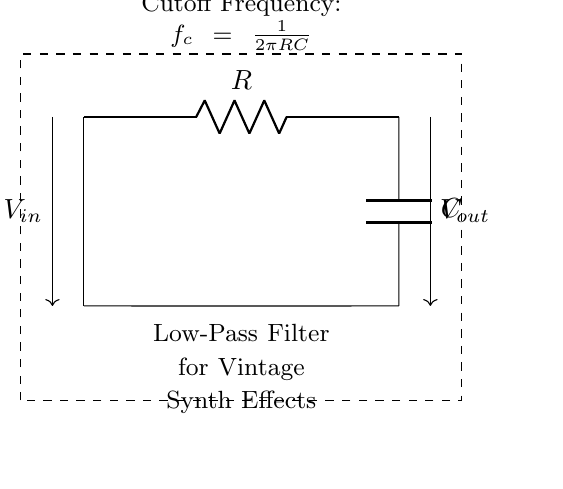What type of components are present in the circuit? The circuit consists of a resistor and a capacitor, which are the two essential components in a low-pass filter. The resistor is labeled as R, and the capacitor is labeled as C.
Answer: Resistor, Capacitor What is the purpose of the low-pass filter? The low-pass filter allows signals with a frequency lower than a certain cutoff frequency to pass through while attenuating higher-frequency signals. This is ideal for creating retro sound effects in synthesizers.
Answer: Attenuates high-frequency signals What is the formula for the cutoff frequency in this circuit? The formula for the cutoff frequency (f_c) is given as f_c = 1/(2πRC), where R is the resistance, and C is the capacitance. This formula helps in determining how the filter operates based on its components.
Answer: 1/(2πRC) How does increasing the value of the capacitor affect the cutoff frequency? Increasing the capacitor value (C) will lower the cutoff frequency (f_c), allowing more low-frequency signals to pass through while blocking higher frequencies. This results in a deeper, more pronounced retro effect.
Answer: Lowers cutoff frequency What happens to the output voltage as the frequency increases? As the frequency of the input signal increases beyond the cutoff frequency, the output voltage (V_out) decreases, reflecting the filter's attenuation of high-frequency components. This is consistent with the behavior of a low-pass filter.
Answer: Decreases What is the relation between resistance and cutoff frequency? Increasing the resistance (R) will result in a higher cutoff frequency (f_c), which means the filter will allow fewer low frequencies to pass and more high frequencies. This relationship can be derived from the cutoff frequency formula.
Answer: Higher resistance raises cutoff frequency 